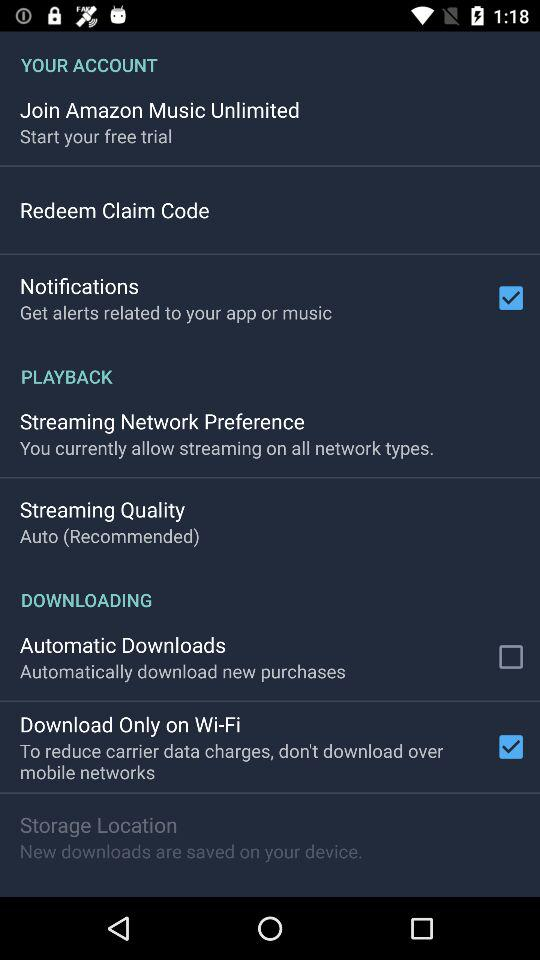What is the status of "Automatic Downloads"? The status is "off". 